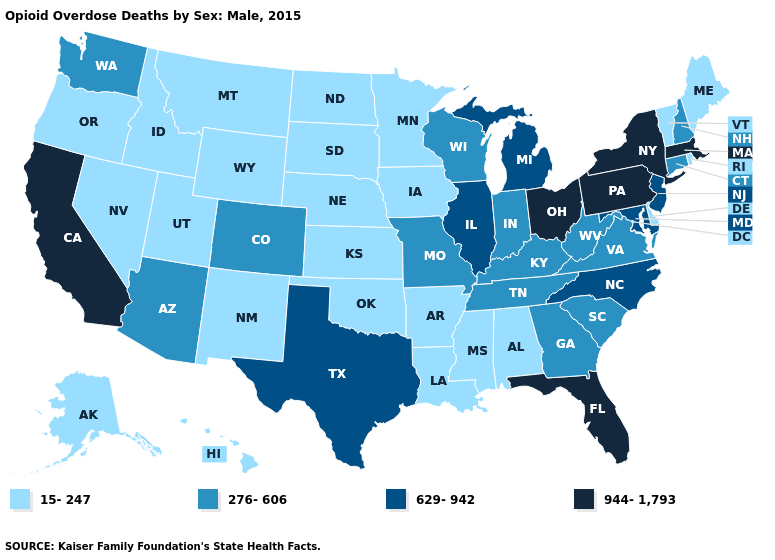Name the states that have a value in the range 944-1,793?
Concise answer only. California, Florida, Massachusetts, New York, Ohio, Pennsylvania. What is the lowest value in the USA?
Write a very short answer. 15-247. What is the value of New York?
Short answer required. 944-1,793. Does Arkansas have the highest value in the USA?
Keep it brief. No. What is the value of New Hampshire?
Be succinct. 276-606. Name the states that have a value in the range 15-247?
Keep it brief. Alabama, Alaska, Arkansas, Delaware, Hawaii, Idaho, Iowa, Kansas, Louisiana, Maine, Minnesota, Mississippi, Montana, Nebraska, Nevada, New Mexico, North Dakota, Oklahoma, Oregon, Rhode Island, South Dakota, Utah, Vermont, Wyoming. Does South Carolina have the highest value in the South?
Write a very short answer. No. Name the states that have a value in the range 276-606?
Concise answer only. Arizona, Colorado, Connecticut, Georgia, Indiana, Kentucky, Missouri, New Hampshire, South Carolina, Tennessee, Virginia, Washington, West Virginia, Wisconsin. Does the map have missing data?
Write a very short answer. No. Which states have the highest value in the USA?
Give a very brief answer. California, Florida, Massachusetts, New York, Ohio, Pennsylvania. What is the lowest value in the USA?
Concise answer only. 15-247. Which states have the lowest value in the MidWest?
Be succinct. Iowa, Kansas, Minnesota, Nebraska, North Dakota, South Dakota. Does the map have missing data?
Give a very brief answer. No. How many symbols are there in the legend?
Quick response, please. 4. What is the value of New Jersey?
Concise answer only. 629-942. 